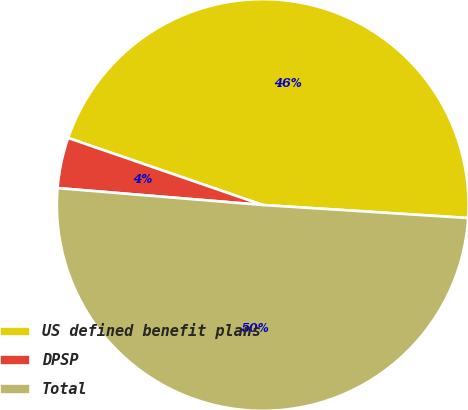<chart> <loc_0><loc_0><loc_500><loc_500><pie_chart><fcel>US defined benefit plans<fcel>DPSP<fcel>Total<nl><fcel>45.73%<fcel>3.97%<fcel>50.3%<nl></chart> 